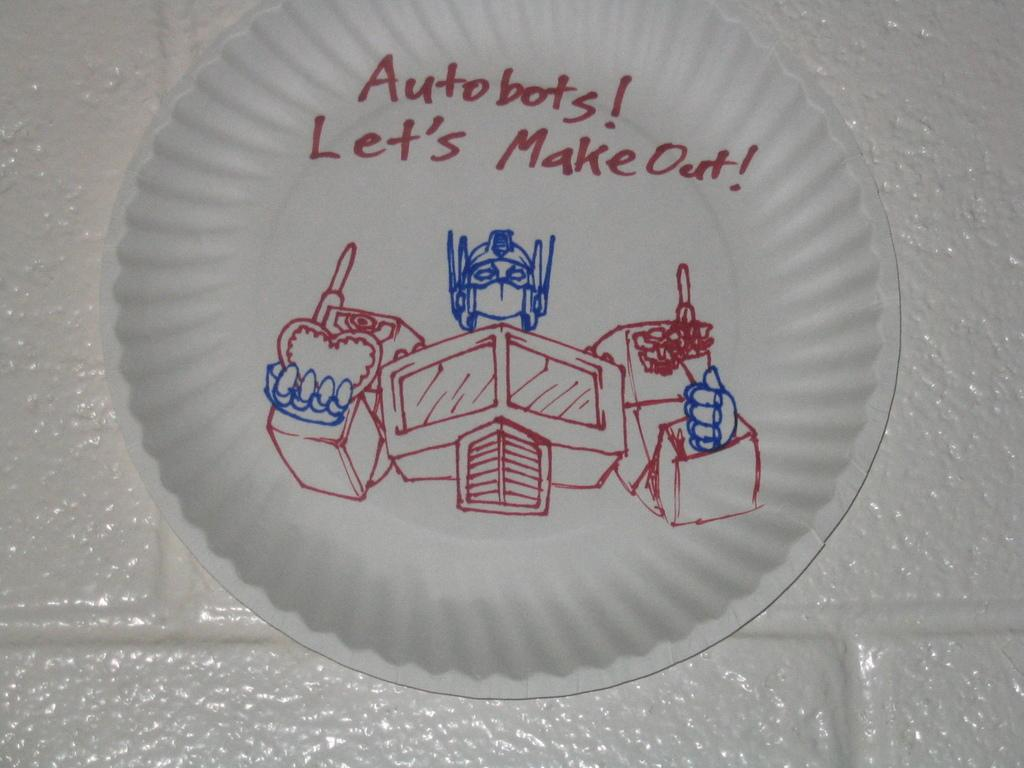What is present on the plate in the image? There is text and a diagram on the plate in the image. What type of information might the text and diagram convey? The text and diagram might provide information or instructions related to the plate's content or purpose. Can you describe the appearance of the text and diagram? Unfortunately, the appearance of the text and diagram cannot be described without more information about their content or style. How many mice are shown interacting with the text and diagram on the plate? There are no mice present in the image; it only features text and a diagram on a plate. What type of chicken is depicted in the diagram? There is no chicken depicted in the image; it only features text and a diagram on a plate. 